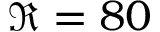<formula> <loc_0><loc_0><loc_500><loc_500>\Re = 8 0</formula> 